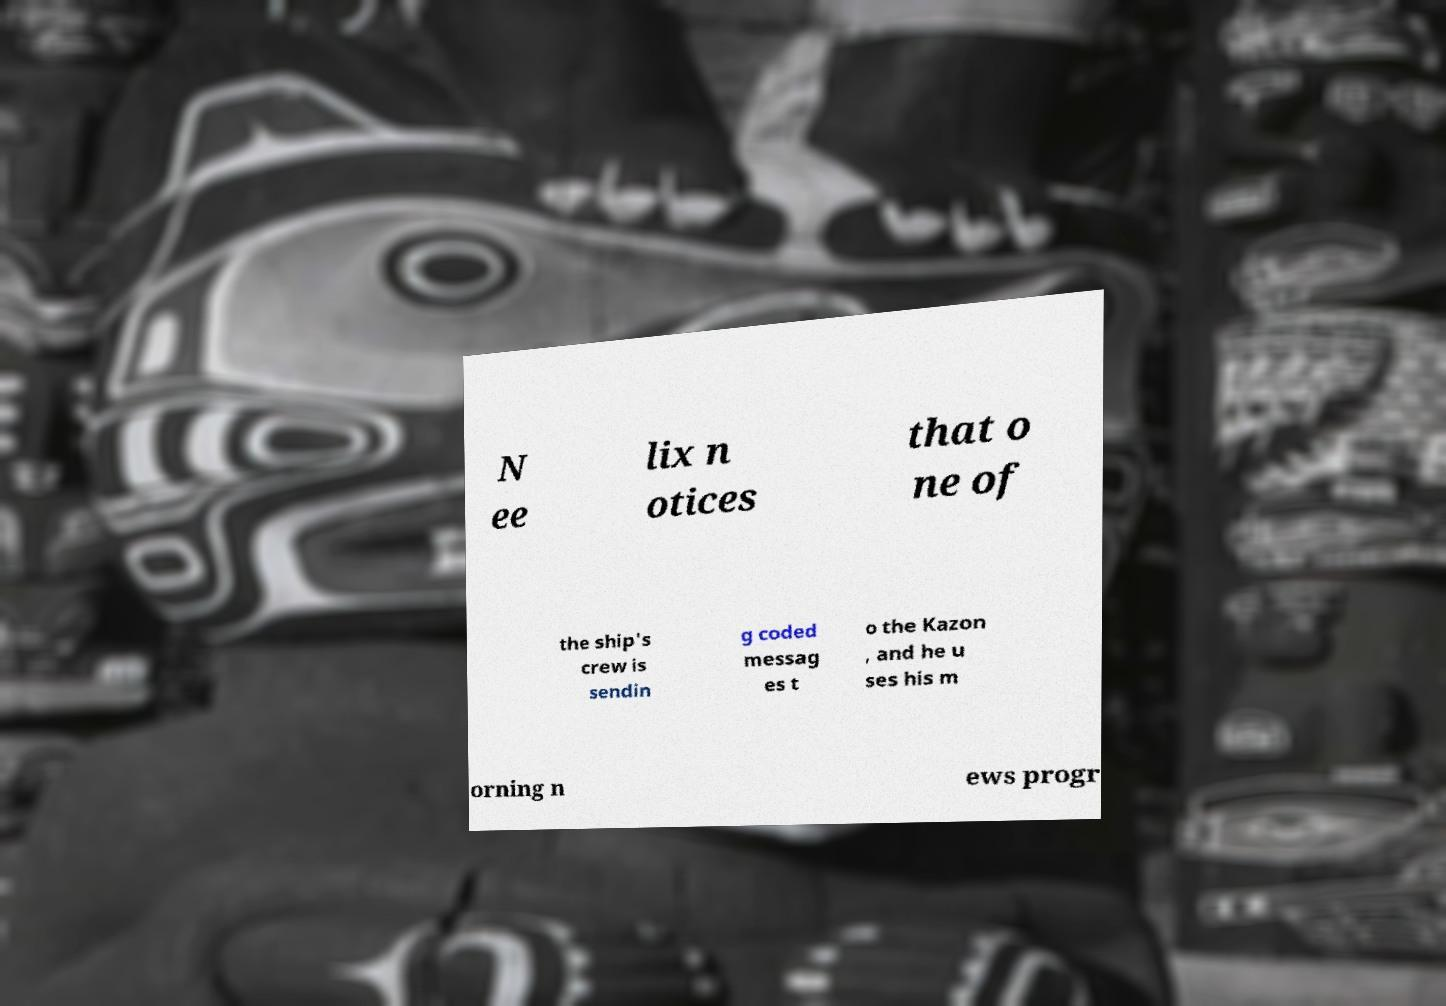I need the written content from this picture converted into text. Can you do that? N ee lix n otices that o ne of the ship's crew is sendin g coded messag es t o the Kazon , and he u ses his m orning n ews progr 